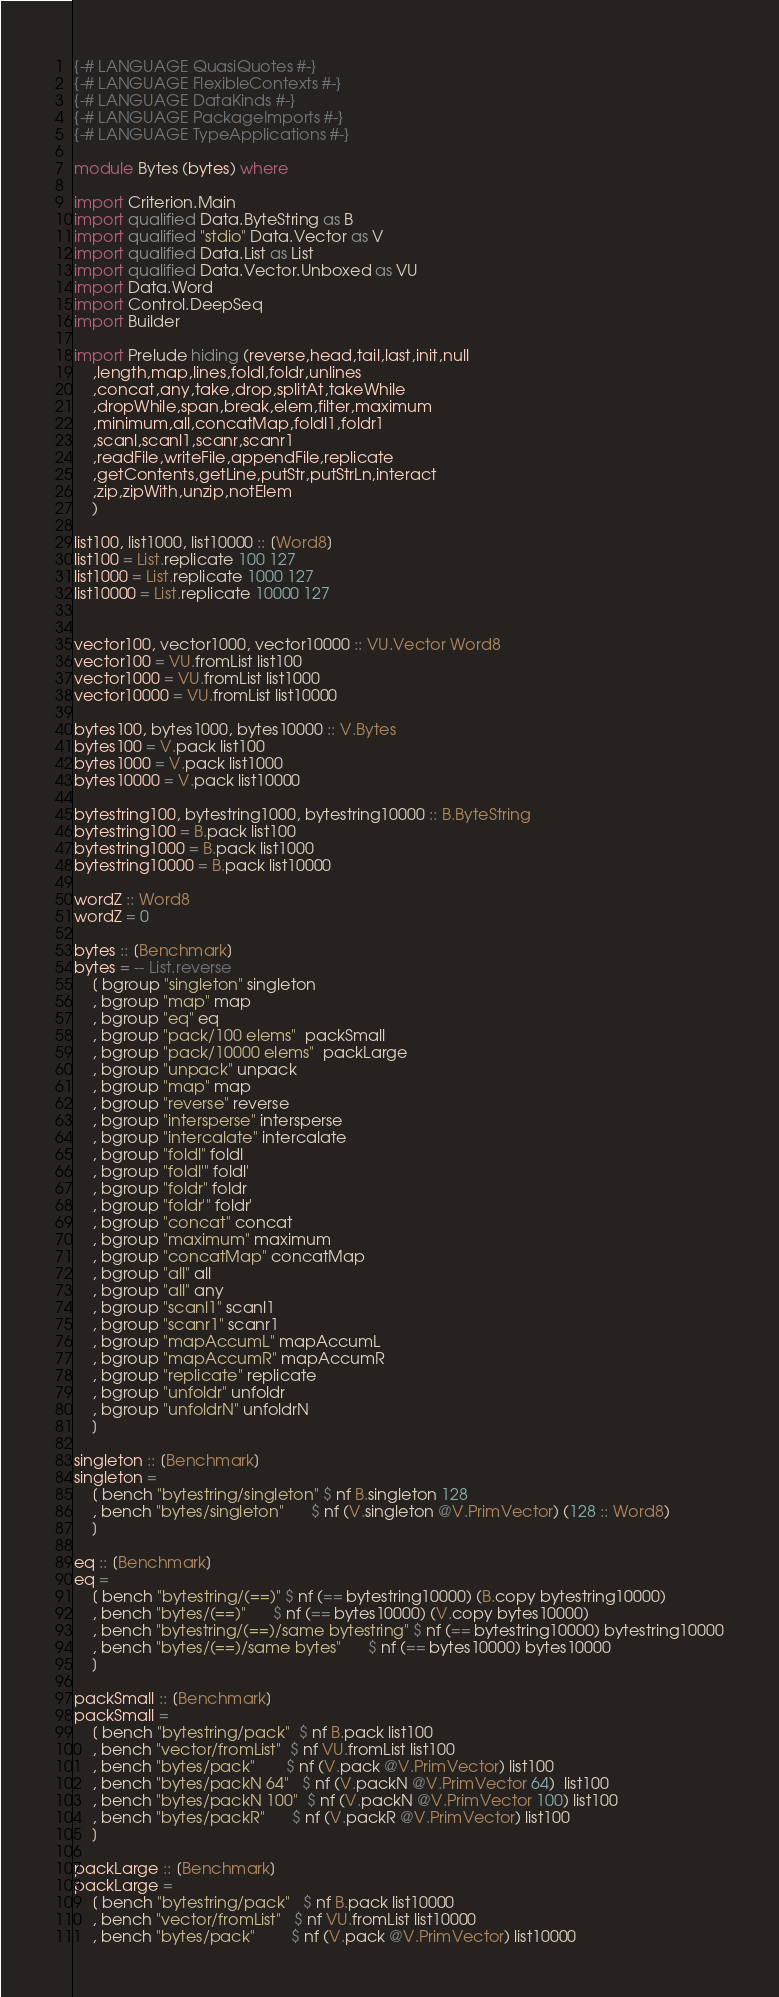Convert code to text. <code><loc_0><loc_0><loc_500><loc_500><_Haskell_>{-# LANGUAGE QuasiQuotes #-}
{-# LANGUAGE FlexibleContexts #-}
{-# LANGUAGE DataKinds #-}
{-# LANGUAGE PackageImports #-}
{-# LANGUAGE TypeApplications #-}

module Bytes (bytes) where

import Criterion.Main
import qualified Data.ByteString as B
import qualified "stdio" Data.Vector as V
import qualified Data.List as List
import qualified Data.Vector.Unboxed as VU
import Data.Word
import Control.DeepSeq
import Builder

import Prelude hiding (reverse,head,tail,last,init,null
    ,length,map,lines,foldl,foldr,unlines
    ,concat,any,take,drop,splitAt,takeWhile
    ,dropWhile,span,break,elem,filter,maximum
    ,minimum,all,concatMap,foldl1,foldr1
    ,scanl,scanl1,scanr,scanr1
    ,readFile,writeFile,appendFile,replicate
    ,getContents,getLine,putStr,putStrLn,interact
    ,zip,zipWith,unzip,notElem
    )

list100, list1000, list10000 :: [Word8]
list100 = List.replicate 100 127
list1000 = List.replicate 1000 127
list10000 = List.replicate 10000 127


vector100, vector1000, vector10000 :: VU.Vector Word8
vector100 = VU.fromList list100
vector1000 = VU.fromList list1000
vector10000 = VU.fromList list10000

bytes100, bytes1000, bytes10000 :: V.Bytes
bytes100 = V.pack list100
bytes1000 = V.pack list1000
bytes10000 = V.pack list10000

bytestring100, bytestring1000, bytestring10000 :: B.ByteString
bytestring100 = B.pack list100
bytestring1000 = B.pack list1000
bytestring10000 = B.pack list10000

wordZ :: Word8
wordZ = 0

bytes :: [Benchmark]
bytes = -- List.reverse
    [ bgroup "singleton" singleton
    , bgroup "map" map
    , bgroup "eq" eq
    , bgroup "pack/100 elems"  packSmall
    , bgroup "pack/10000 elems"  packLarge
    , bgroup "unpack" unpack
    , bgroup "map" map
    , bgroup "reverse" reverse
    , bgroup "intersperse" intersperse
    , bgroup "intercalate" intercalate
    , bgroup "foldl" foldl
    , bgroup "foldl'" foldl'
    , bgroup "foldr" foldr
    , bgroup "foldr'" foldr'
    , bgroup "concat" concat
    , bgroup "maximum" maximum
    , bgroup "concatMap" concatMap
    , bgroup "all" all
    , bgroup "all" any
    , bgroup "scanl1" scanl1
    , bgroup "scanr1" scanr1
    , bgroup "mapAccumL" mapAccumL
    , bgroup "mapAccumR" mapAccumR
    , bgroup "replicate" replicate
    , bgroup "unfoldr" unfoldr
    , bgroup "unfoldrN" unfoldrN
    ]

singleton :: [Benchmark]
singleton =
    [ bench "bytestring/singleton" $ nf B.singleton 128
    , bench "bytes/singleton"      $ nf (V.singleton @V.PrimVector) (128 :: Word8)
    ]

eq :: [Benchmark]
eq =
    [ bench "bytestring/(==)" $ nf (== bytestring10000) (B.copy bytestring10000)
    , bench "bytes/(==)"      $ nf (== bytes10000) (V.copy bytes10000)
    , bench "bytestring/(==)/same bytestring" $ nf (== bytestring10000) bytestring10000
    , bench "bytes/(==)/same bytes"      $ nf (== bytes10000) bytes10000
    ]

packSmall :: [Benchmark]
packSmall =
    [ bench "bytestring/pack"  $ nf B.pack list100
    , bench "vector/fromList"  $ nf VU.fromList list100
    , bench "bytes/pack"       $ nf (V.pack @V.PrimVector) list100
    , bench "bytes/packN 64"   $ nf (V.packN @V.PrimVector 64)  list100
    , bench "bytes/packN 100"  $ nf (V.packN @V.PrimVector 100) list100
    , bench "bytes/packR"      $ nf (V.packR @V.PrimVector) list100
    ]

packLarge :: [Benchmark]
packLarge =
    [ bench "bytestring/pack"   $ nf B.pack list10000
    , bench "vector/fromList"   $ nf VU.fromList list10000
    , bench "bytes/pack"        $ nf (V.pack @V.PrimVector) list10000</code> 